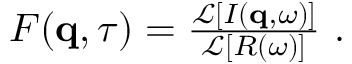<formula> <loc_0><loc_0><loc_500><loc_500>\begin{array} { r } { F ( q , \tau ) = \frac { \mathcal { L } \left [ I ( q , \omega ) \right ] } { \mathcal { L } \left [ R ( \omega ) \right ] } \ . } \end{array}</formula> 